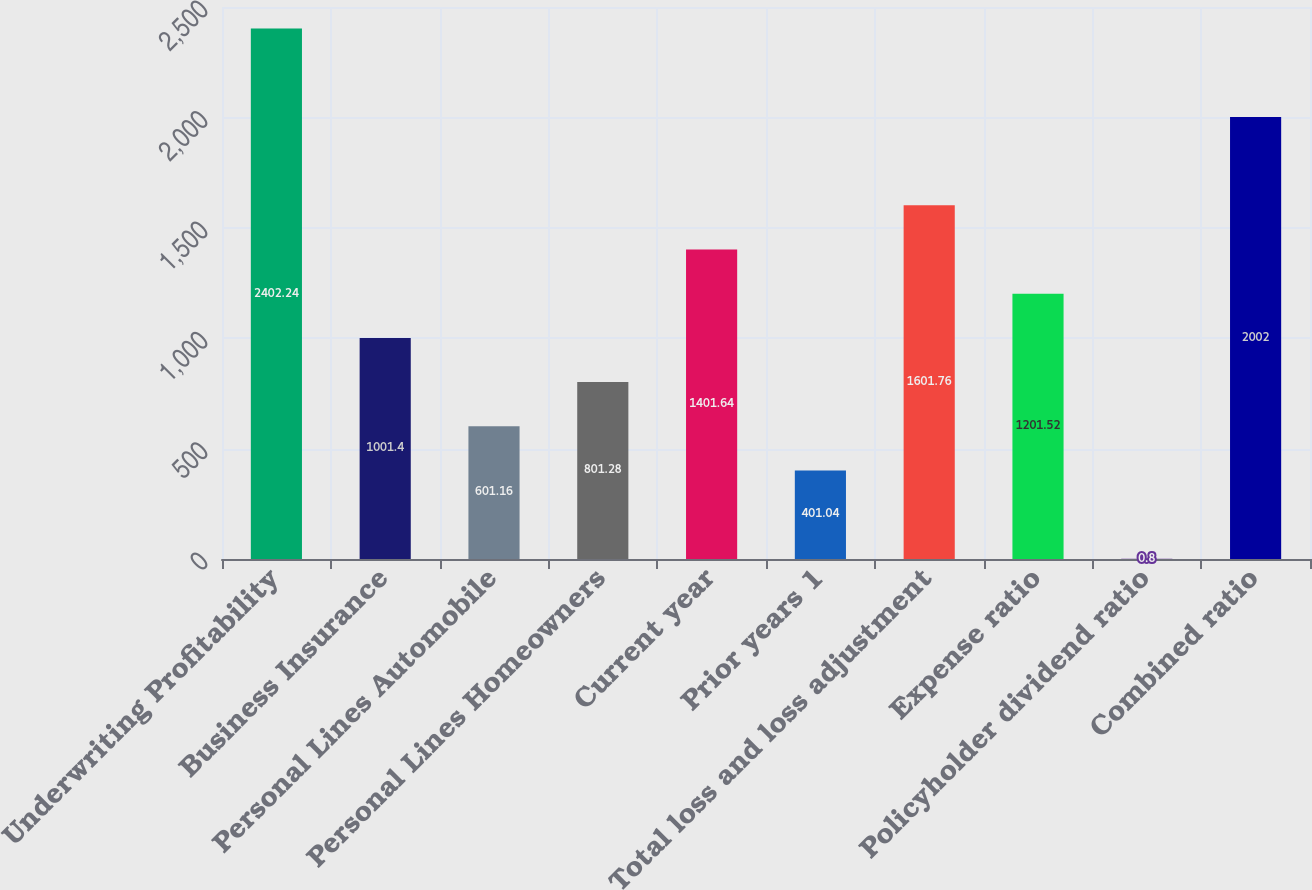Convert chart to OTSL. <chart><loc_0><loc_0><loc_500><loc_500><bar_chart><fcel>Underwriting Profitability<fcel>Business Insurance<fcel>Personal Lines Automobile<fcel>Personal Lines Homeowners<fcel>Current year<fcel>Prior years 1<fcel>Total loss and loss adjustment<fcel>Expense ratio<fcel>Policyholder dividend ratio<fcel>Combined ratio<nl><fcel>2402.24<fcel>1001.4<fcel>601.16<fcel>801.28<fcel>1401.64<fcel>401.04<fcel>1601.76<fcel>1201.52<fcel>0.8<fcel>2002<nl></chart> 